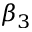<formula> <loc_0><loc_0><loc_500><loc_500>\beta _ { 3 }</formula> 